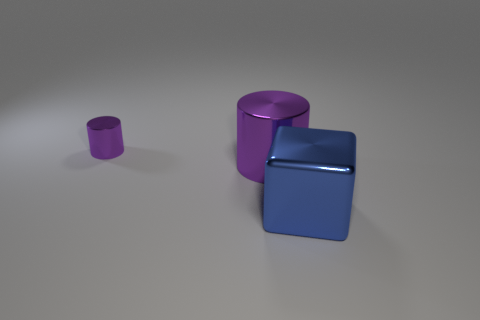Add 2 big purple things. How many objects exist? 5 Subtract all cubes. How many objects are left? 2 Add 3 blue shiny things. How many blue shiny things are left? 4 Add 2 blue things. How many blue things exist? 3 Subtract 0 yellow cubes. How many objects are left? 3 Subtract all blue matte blocks. Subtract all metal things. How many objects are left? 0 